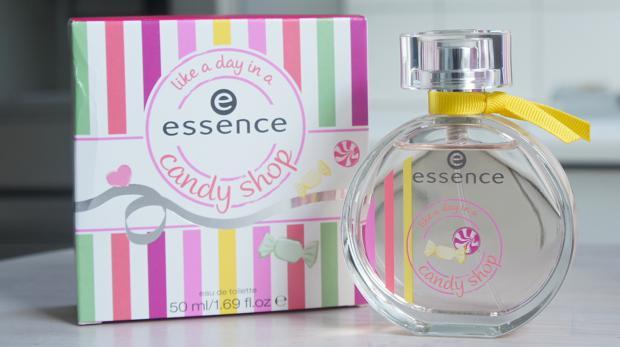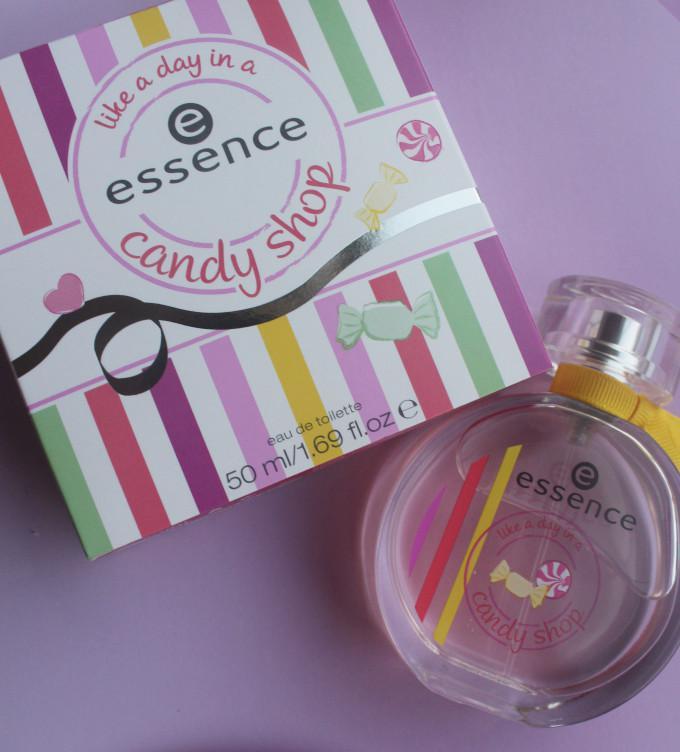The first image is the image on the left, the second image is the image on the right. Given the left and right images, does the statement "Both images show a circular perfume bottle next to a candy-striped box." hold true? Answer yes or no. Yes. 